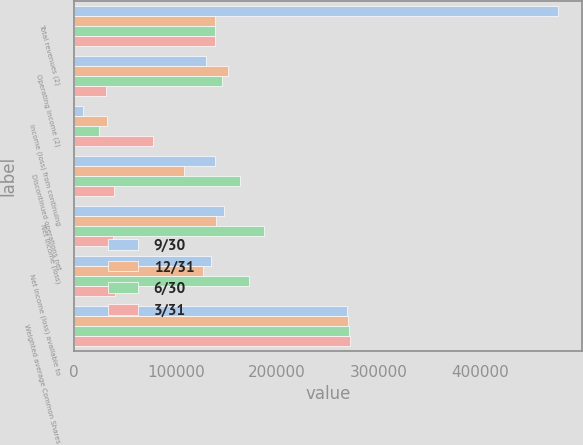Convert chart to OTSL. <chart><loc_0><loc_0><loc_500><loc_500><stacked_bar_chart><ecel><fcel>Total revenues (2)<fcel>Operating income (2)<fcel>Income (loss) from continuing<fcel>Discontinued operations net<fcel>Net income (loss)<fcel>Net income (loss) available to<fcel>Weighted average Common Shares<nl><fcel>9/30<fcel>476035<fcel>129593<fcel>8504<fcel>139024<fcel>147528<fcel>134490<fcel>268784<nl><fcel>12/31<fcel>139024<fcel>151215<fcel>32239<fcel>107754<fcel>139993<fcel>126625<fcel>269608<nl><fcel>6/30<fcel>139024<fcel>145954<fcel>24118<fcel>163007<fcel>187125<fcel>172246<fcel>270345<nl><fcel>3/31<fcel>139024<fcel>31396<fcel>77684<fcel>39451<fcel>38233<fcel>40246<fcel>271293<nl></chart> 